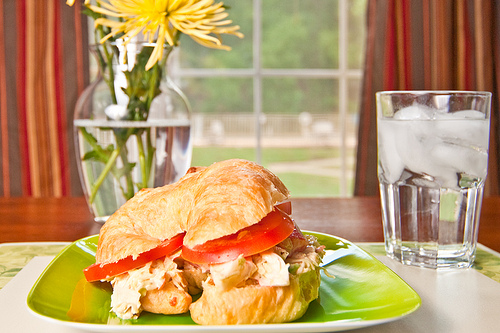Which is healthier, the croissant or the tomato? The tomato is the healthier option compared to the croissant. 